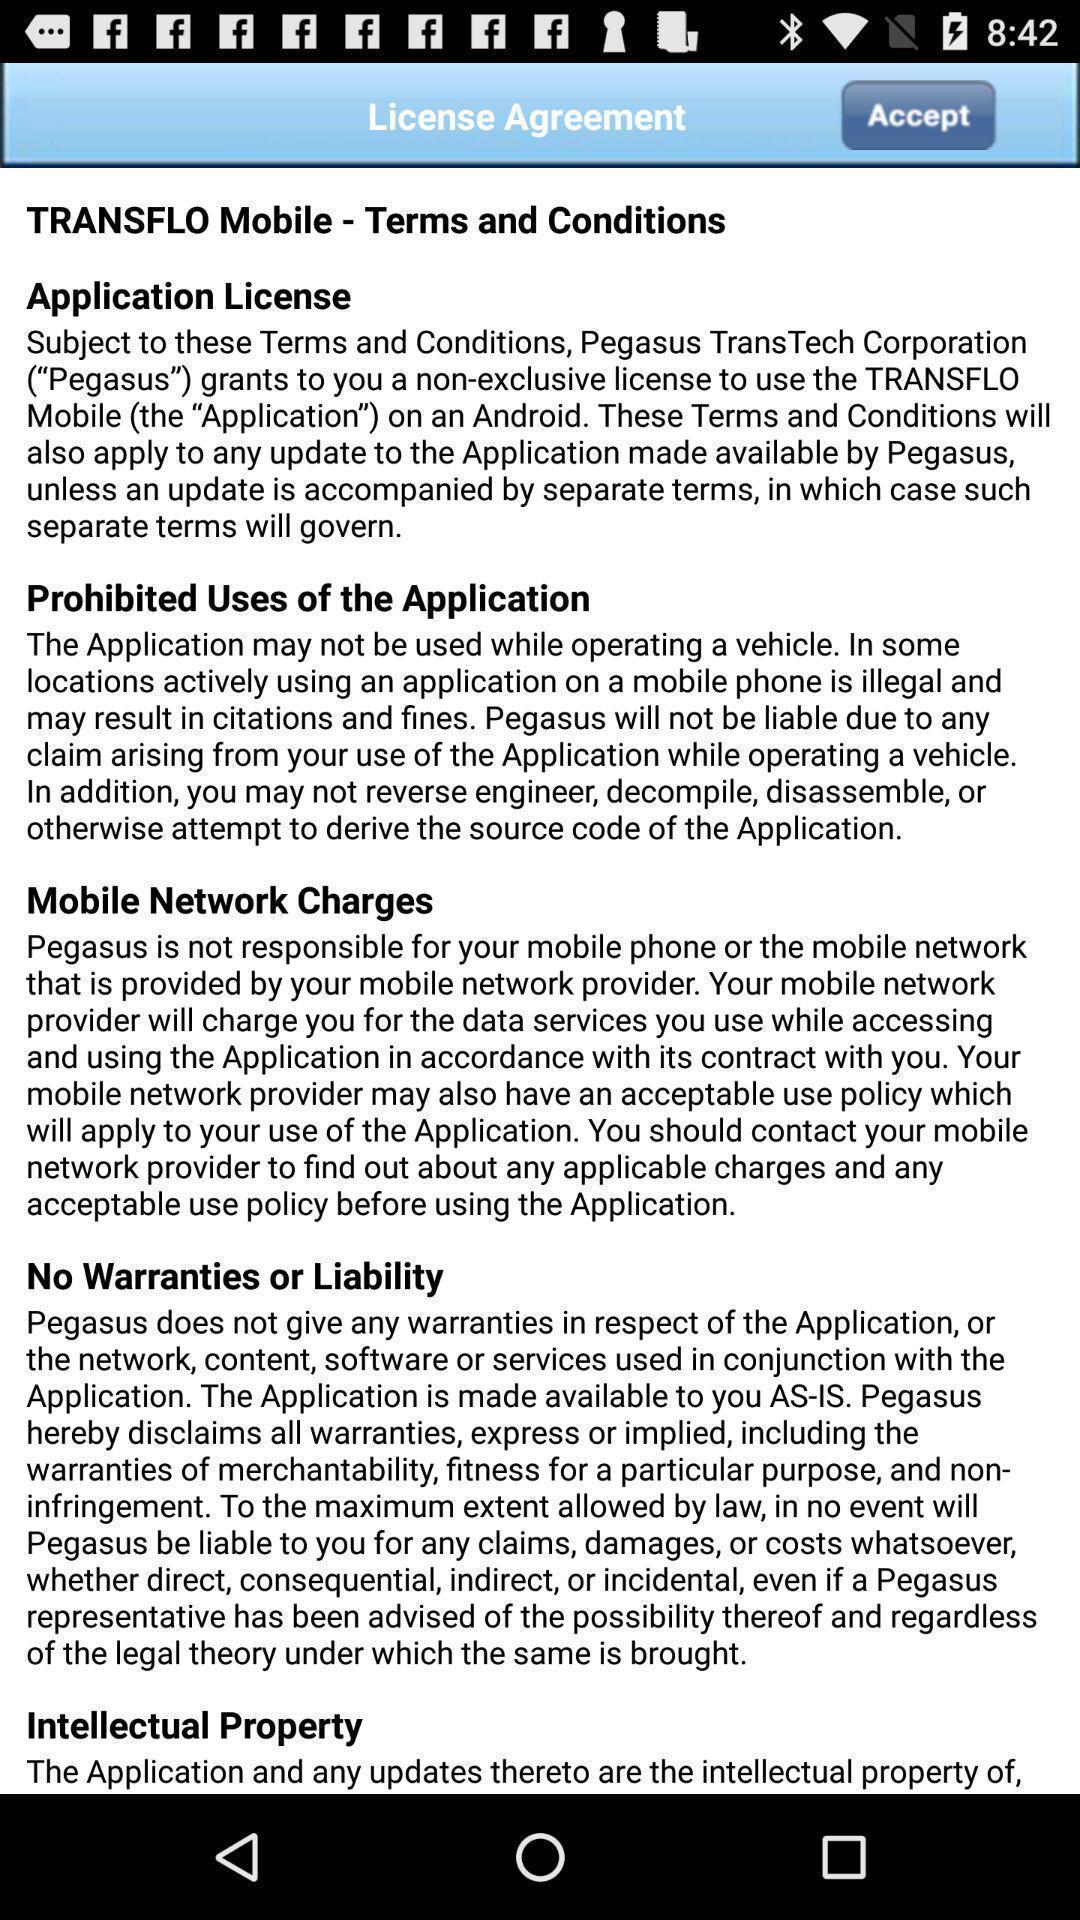What details can you identify in this image? Page showing terms and conditions. 